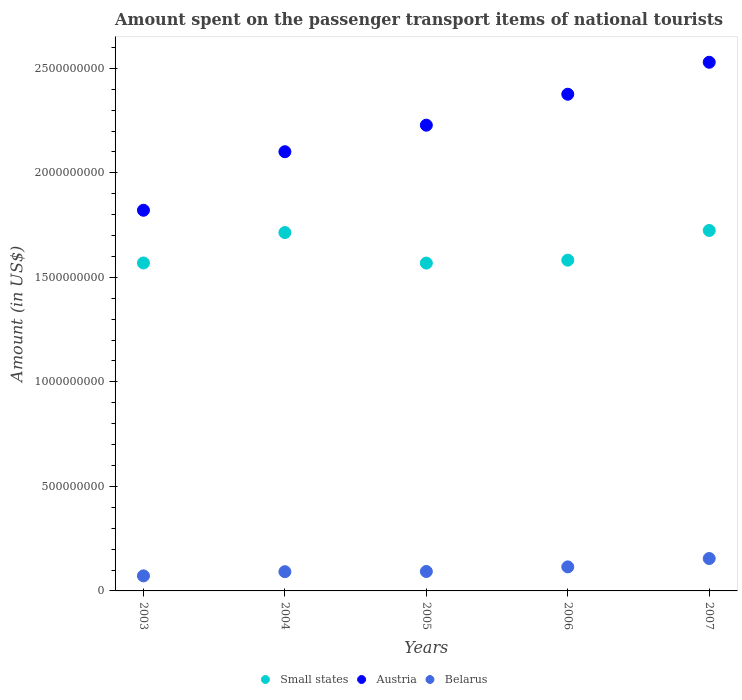What is the amount spent on the passenger transport items of national tourists in Belarus in 2007?
Offer a terse response. 1.55e+08. Across all years, what is the maximum amount spent on the passenger transport items of national tourists in Small states?
Offer a terse response. 1.72e+09. Across all years, what is the minimum amount spent on the passenger transport items of national tourists in Belarus?
Your answer should be very brief. 7.20e+07. In which year was the amount spent on the passenger transport items of national tourists in Belarus maximum?
Give a very brief answer. 2007. In which year was the amount spent on the passenger transport items of national tourists in Austria minimum?
Your answer should be compact. 2003. What is the total amount spent on the passenger transport items of national tourists in Small states in the graph?
Your answer should be very brief. 8.16e+09. What is the difference between the amount spent on the passenger transport items of national tourists in Austria in 2004 and that in 2006?
Provide a short and direct response. -2.75e+08. What is the difference between the amount spent on the passenger transport items of national tourists in Small states in 2004 and the amount spent on the passenger transport items of national tourists in Austria in 2003?
Make the answer very short. -1.07e+08. What is the average amount spent on the passenger transport items of national tourists in Small states per year?
Provide a short and direct response. 1.63e+09. In the year 2004, what is the difference between the amount spent on the passenger transport items of national tourists in Austria and amount spent on the passenger transport items of national tourists in Belarus?
Make the answer very short. 2.01e+09. In how many years, is the amount spent on the passenger transport items of national tourists in Austria greater than 600000000 US$?
Offer a very short reply. 5. What is the ratio of the amount spent on the passenger transport items of national tourists in Belarus in 2003 to that in 2004?
Your answer should be compact. 0.78. Is the amount spent on the passenger transport items of national tourists in Small states in 2005 less than that in 2007?
Provide a succinct answer. Yes. What is the difference between the highest and the second highest amount spent on the passenger transport items of national tourists in Austria?
Keep it short and to the point. 1.53e+08. What is the difference between the highest and the lowest amount spent on the passenger transport items of national tourists in Belarus?
Offer a terse response. 8.30e+07. Is the sum of the amount spent on the passenger transport items of national tourists in Austria in 2005 and 2007 greater than the maximum amount spent on the passenger transport items of national tourists in Belarus across all years?
Your answer should be compact. Yes. Is it the case that in every year, the sum of the amount spent on the passenger transport items of national tourists in Small states and amount spent on the passenger transport items of national tourists in Belarus  is greater than the amount spent on the passenger transport items of national tourists in Austria?
Offer a terse response. No. Is the amount spent on the passenger transport items of national tourists in Belarus strictly greater than the amount spent on the passenger transport items of national tourists in Austria over the years?
Your answer should be very brief. No. How many years are there in the graph?
Provide a succinct answer. 5. What is the difference between two consecutive major ticks on the Y-axis?
Keep it short and to the point. 5.00e+08. Are the values on the major ticks of Y-axis written in scientific E-notation?
Provide a succinct answer. No. Where does the legend appear in the graph?
Offer a very short reply. Bottom center. How are the legend labels stacked?
Keep it short and to the point. Horizontal. What is the title of the graph?
Give a very brief answer. Amount spent on the passenger transport items of national tourists. What is the label or title of the X-axis?
Make the answer very short. Years. What is the label or title of the Y-axis?
Ensure brevity in your answer.  Amount (in US$). What is the Amount (in US$) of Small states in 2003?
Give a very brief answer. 1.57e+09. What is the Amount (in US$) in Austria in 2003?
Your answer should be very brief. 1.82e+09. What is the Amount (in US$) of Belarus in 2003?
Offer a terse response. 7.20e+07. What is the Amount (in US$) of Small states in 2004?
Give a very brief answer. 1.71e+09. What is the Amount (in US$) in Austria in 2004?
Provide a short and direct response. 2.10e+09. What is the Amount (in US$) in Belarus in 2004?
Give a very brief answer. 9.20e+07. What is the Amount (in US$) of Small states in 2005?
Provide a succinct answer. 1.57e+09. What is the Amount (in US$) in Austria in 2005?
Make the answer very short. 2.23e+09. What is the Amount (in US$) of Belarus in 2005?
Your response must be concise. 9.30e+07. What is the Amount (in US$) of Small states in 2006?
Make the answer very short. 1.58e+09. What is the Amount (in US$) in Austria in 2006?
Your response must be concise. 2.38e+09. What is the Amount (in US$) of Belarus in 2006?
Offer a very short reply. 1.15e+08. What is the Amount (in US$) of Small states in 2007?
Provide a succinct answer. 1.72e+09. What is the Amount (in US$) of Austria in 2007?
Make the answer very short. 2.53e+09. What is the Amount (in US$) of Belarus in 2007?
Make the answer very short. 1.55e+08. Across all years, what is the maximum Amount (in US$) of Small states?
Give a very brief answer. 1.72e+09. Across all years, what is the maximum Amount (in US$) in Austria?
Your answer should be compact. 2.53e+09. Across all years, what is the maximum Amount (in US$) of Belarus?
Your response must be concise. 1.55e+08. Across all years, what is the minimum Amount (in US$) of Small states?
Provide a short and direct response. 1.57e+09. Across all years, what is the minimum Amount (in US$) of Austria?
Offer a very short reply. 1.82e+09. Across all years, what is the minimum Amount (in US$) of Belarus?
Make the answer very short. 7.20e+07. What is the total Amount (in US$) of Small states in the graph?
Offer a very short reply. 8.16e+09. What is the total Amount (in US$) of Austria in the graph?
Ensure brevity in your answer.  1.11e+1. What is the total Amount (in US$) in Belarus in the graph?
Ensure brevity in your answer.  5.27e+08. What is the difference between the Amount (in US$) of Small states in 2003 and that in 2004?
Offer a very short reply. -1.45e+08. What is the difference between the Amount (in US$) of Austria in 2003 and that in 2004?
Your answer should be compact. -2.80e+08. What is the difference between the Amount (in US$) of Belarus in 2003 and that in 2004?
Give a very brief answer. -2.00e+07. What is the difference between the Amount (in US$) of Small states in 2003 and that in 2005?
Provide a short and direct response. 5.74e+05. What is the difference between the Amount (in US$) of Austria in 2003 and that in 2005?
Your response must be concise. -4.07e+08. What is the difference between the Amount (in US$) of Belarus in 2003 and that in 2005?
Your response must be concise. -2.10e+07. What is the difference between the Amount (in US$) of Small states in 2003 and that in 2006?
Keep it short and to the point. -1.35e+07. What is the difference between the Amount (in US$) in Austria in 2003 and that in 2006?
Your answer should be compact. -5.55e+08. What is the difference between the Amount (in US$) of Belarus in 2003 and that in 2006?
Offer a very short reply. -4.30e+07. What is the difference between the Amount (in US$) in Small states in 2003 and that in 2007?
Keep it short and to the point. -1.55e+08. What is the difference between the Amount (in US$) of Austria in 2003 and that in 2007?
Make the answer very short. -7.08e+08. What is the difference between the Amount (in US$) of Belarus in 2003 and that in 2007?
Offer a very short reply. -8.30e+07. What is the difference between the Amount (in US$) of Small states in 2004 and that in 2005?
Give a very brief answer. 1.46e+08. What is the difference between the Amount (in US$) in Austria in 2004 and that in 2005?
Your answer should be compact. -1.27e+08. What is the difference between the Amount (in US$) in Small states in 2004 and that in 2006?
Offer a terse response. 1.32e+08. What is the difference between the Amount (in US$) of Austria in 2004 and that in 2006?
Give a very brief answer. -2.75e+08. What is the difference between the Amount (in US$) of Belarus in 2004 and that in 2006?
Offer a terse response. -2.30e+07. What is the difference between the Amount (in US$) of Small states in 2004 and that in 2007?
Make the answer very short. -9.98e+06. What is the difference between the Amount (in US$) in Austria in 2004 and that in 2007?
Keep it short and to the point. -4.28e+08. What is the difference between the Amount (in US$) of Belarus in 2004 and that in 2007?
Offer a very short reply. -6.30e+07. What is the difference between the Amount (in US$) in Small states in 2005 and that in 2006?
Provide a short and direct response. -1.40e+07. What is the difference between the Amount (in US$) in Austria in 2005 and that in 2006?
Make the answer very short. -1.48e+08. What is the difference between the Amount (in US$) of Belarus in 2005 and that in 2006?
Your answer should be very brief. -2.20e+07. What is the difference between the Amount (in US$) of Small states in 2005 and that in 2007?
Provide a succinct answer. -1.56e+08. What is the difference between the Amount (in US$) of Austria in 2005 and that in 2007?
Offer a terse response. -3.01e+08. What is the difference between the Amount (in US$) in Belarus in 2005 and that in 2007?
Make the answer very short. -6.20e+07. What is the difference between the Amount (in US$) of Small states in 2006 and that in 2007?
Offer a very short reply. -1.42e+08. What is the difference between the Amount (in US$) in Austria in 2006 and that in 2007?
Ensure brevity in your answer.  -1.53e+08. What is the difference between the Amount (in US$) in Belarus in 2006 and that in 2007?
Make the answer very short. -4.00e+07. What is the difference between the Amount (in US$) of Small states in 2003 and the Amount (in US$) of Austria in 2004?
Make the answer very short. -5.32e+08. What is the difference between the Amount (in US$) of Small states in 2003 and the Amount (in US$) of Belarus in 2004?
Ensure brevity in your answer.  1.48e+09. What is the difference between the Amount (in US$) in Austria in 2003 and the Amount (in US$) in Belarus in 2004?
Make the answer very short. 1.73e+09. What is the difference between the Amount (in US$) of Small states in 2003 and the Amount (in US$) of Austria in 2005?
Your answer should be compact. -6.59e+08. What is the difference between the Amount (in US$) of Small states in 2003 and the Amount (in US$) of Belarus in 2005?
Your response must be concise. 1.48e+09. What is the difference between the Amount (in US$) in Austria in 2003 and the Amount (in US$) in Belarus in 2005?
Give a very brief answer. 1.73e+09. What is the difference between the Amount (in US$) of Small states in 2003 and the Amount (in US$) of Austria in 2006?
Give a very brief answer. -8.07e+08. What is the difference between the Amount (in US$) in Small states in 2003 and the Amount (in US$) in Belarus in 2006?
Your answer should be compact. 1.45e+09. What is the difference between the Amount (in US$) in Austria in 2003 and the Amount (in US$) in Belarus in 2006?
Offer a very short reply. 1.71e+09. What is the difference between the Amount (in US$) in Small states in 2003 and the Amount (in US$) in Austria in 2007?
Offer a terse response. -9.60e+08. What is the difference between the Amount (in US$) of Small states in 2003 and the Amount (in US$) of Belarus in 2007?
Make the answer very short. 1.41e+09. What is the difference between the Amount (in US$) in Austria in 2003 and the Amount (in US$) in Belarus in 2007?
Provide a short and direct response. 1.67e+09. What is the difference between the Amount (in US$) in Small states in 2004 and the Amount (in US$) in Austria in 2005?
Your response must be concise. -5.14e+08. What is the difference between the Amount (in US$) of Small states in 2004 and the Amount (in US$) of Belarus in 2005?
Ensure brevity in your answer.  1.62e+09. What is the difference between the Amount (in US$) of Austria in 2004 and the Amount (in US$) of Belarus in 2005?
Offer a very short reply. 2.01e+09. What is the difference between the Amount (in US$) of Small states in 2004 and the Amount (in US$) of Austria in 2006?
Offer a very short reply. -6.62e+08. What is the difference between the Amount (in US$) in Small states in 2004 and the Amount (in US$) in Belarus in 2006?
Offer a very short reply. 1.60e+09. What is the difference between the Amount (in US$) in Austria in 2004 and the Amount (in US$) in Belarus in 2006?
Keep it short and to the point. 1.99e+09. What is the difference between the Amount (in US$) of Small states in 2004 and the Amount (in US$) of Austria in 2007?
Provide a succinct answer. -8.15e+08. What is the difference between the Amount (in US$) of Small states in 2004 and the Amount (in US$) of Belarus in 2007?
Ensure brevity in your answer.  1.56e+09. What is the difference between the Amount (in US$) in Austria in 2004 and the Amount (in US$) in Belarus in 2007?
Give a very brief answer. 1.95e+09. What is the difference between the Amount (in US$) in Small states in 2005 and the Amount (in US$) in Austria in 2006?
Your answer should be very brief. -8.08e+08. What is the difference between the Amount (in US$) in Small states in 2005 and the Amount (in US$) in Belarus in 2006?
Give a very brief answer. 1.45e+09. What is the difference between the Amount (in US$) of Austria in 2005 and the Amount (in US$) of Belarus in 2006?
Provide a short and direct response. 2.11e+09. What is the difference between the Amount (in US$) of Small states in 2005 and the Amount (in US$) of Austria in 2007?
Your answer should be very brief. -9.61e+08. What is the difference between the Amount (in US$) of Small states in 2005 and the Amount (in US$) of Belarus in 2007?
Provide a short and direct response. 1.41e+09. What is the difference between the Amount (in US$) of Austria in 2005 and the Amount (in US$) of Belarus in 2007?
Give a very brief answer. 2.07e+09. What is the difference between the Amount (in US$) in Small states in 2006 and the Amount (in US$) in Austria in 2007?
Keep it short and to the point. -9.47e+08. What is the difference between the Amount (in US$) in Small states in 2006 and the Amount (in US$) in Belarus in 2007?
Offer a very short reply. 1.43e+09. What is the difference between the Amount (in US$) in Austria in 2006 and the Amount (in US$) in Belarus in 2007?
Provide a succinct answer. 2.22e+09. What is the average Amount (in US$) in Small states per year?
Provide a short and direct response. 1.63e+09. What is the average Amount (in US$) in Austria per year?
Your answer should be very brief. 2.21e+09. What is the average Amount (in US$) in Belarus per year?
Make the answer very short. 1.05e+08. In the year 2003, what is the difference between the Amount (in US$) of Small states and Amount (in US$) of Austria?
Keep it short and to the point. -2.52e+08. In the year 2003, what is the difference between the Amount (in US$) of Small states and Amount (in US$) of Belarus?
Provide a short and direct response. 1.50e+09. In the year 2003, what is the difference between the Amount (in US$) in Austria and Amount (in US$) in Belarus?
Offer a terse response. 1.75e+09. In the year 2004, what is the difference between the Amount (in US$) of Small states and Amount (in US$) of Austria?
Your answer should be compact. -3.87e+08. In the year 2004, what is the difference between the Amount (in US$) in Small states and Amount (in US$) in Belarus?
Your answer should be compact. 1.62e+09. In the year 2004, what is the difference between the Amount (in US$) in Austria and Amount (in US$) in Belarus?
Offer a very short reply. 2.01e+09. In the year 2005, what is the difference between the Amount (in US$) in Small states and Amount (in US$) in Austria?
Give a very brief answer. -6.60e+08. In the year 2005, what is the difference between the Amount (in US$) in Small states and Amount (in US$) in Belarus?
Make the answer very short. 1.48e+09. In the year 2005, what is the difference between the Amount (in US$) of Austria and Amount (in US$) of Belarus?
Provide a succinct answer. 2.14e+09. In the year 2006, what is the difference between the Amount (in US$) of Small states and Amount (in US$) of Austria?
Keep it short and to the point. -7.94e+08. In the year 2006, what is the difference between the Amount (in US$) in Small states and Amount (in US$) in Belarus?
Offer a very short reply. 1.47e+09. In the year 2006, what is the difference between the Amount (in US$) of Austria and Amount (in US$) of Belarus?
Give a very brief answer. 2.26e+09. In the year 2007, what is the difference between the Amount (in US$) in Small states and Amount (in US$) in Austria?
Give a very brief answer. -8.05e+08. In the year 2007, what is the difference between the Amount (in US$) of Small states and Amount (in US$) of Belarus?
Your answer should be compact. 1.57e+09. In the year 2007, what is the difference between the Amount (in US$) of Austria and Amount (in US$) of Belarus?
Provide a short and direct response. 2.37e+09. What is the ratio of the Amount (in US$) of Small states in 2003 to that in 2004?
Your answer should be very brief. 0.92. What is the ratio of the Amount (in US$) of Austria in 2003 to that in 2004?
Keep it short and to the point. 0.87. What is the ratio of the Amount (in US$) in Belarus in 2003 to that in 2004?
Offer a very short reply. 0.78. What is the ratio of the Amount (in US$) in Small states in 2003 to that in 2005?
Offer a terse response. 1. What is the ratio of the Amount (in US$) in Austria in 2003 to that in 2005?
Ensure brevity in your answer.  0.82. What is the ratio of the Amount (in US$) in Belarus in 2003 to that in 2005?
Your answer should be compact. 0.77. What is the ratio of the Amount (in US$) in Austria in 2003 to that in 2006?
Your response must be concise. 0.77. What is the ratio of the Amount (in US$) in Belarus in 2003 to that in 2006?
Provide a short and direct response. 0.63. What is the ratio of the Amount (in US$) of Small states in 2003 to that in 2007?
Give a very brief answer. 0.91. What is the ratio of the Amount (in US$) of Austria in 2003 to that in 2007?
Offer a terse response. 0.72. What is the ratio of the Amount (in US$) of Belarus in 2003 to that in 2007?
Give a very brief answer. 0.46. What is the ratio of the Amount (in US$) of Small states in 2004 to that in 2005?
Provide a short and direct response. 1.09. What is the ratio of the Amount (in US$) of Austria in 2004 to that in 2005?
Offer a terse response. 0.94. What is the ratio of the Amount (in US$) of Small states in 2004 to that in 2006?
Offer a very short reply. 1.08. What is the ratio of the Amount (in US$) in Austria in 2004 to that in 2006?
Offer a very short reply. 0.88. What is the ratio of the Amount (in US$) in Small states in 2004 to that in 2007?
Provide a short and direct response. 0.99. What is the ratio of the Amount (in US$) of Austria in 2004 to that in 2007?
Ensure brevity in your answer.  0.83. What is the ratio of the Amount (in US$) in Belarus in 2004 to that in 2007?
Keep it short and to the point. 0.59. What is the ratio of the Amount (in US$) of Small states in 2005 to that in 2006?
Provide a succinct answer. 0.99. What is the ratio of the Amount (in US$) of Austria in 2005 to that in 2006?
Your response must be concise. 0.94. What is the ratio of the Amount (in US$) in Belarus in 2005 to that in 2006?
Offer a very short reply. 0.81. What is the ratio of the Amount (in US$) in Small states in 2005 to that in 2007?
Give a very brief answer. 0.91. What is the ratio of the Amount (in US$) in Austria in 2005 to that in 2007?
Offer a terse response. 0.88. What is the ratio of the Amount (in US$) in Small states in 2006 to that in 2007?
Provide a short and direct response. 0.92. What is the ratio of the Amount (in US$) of Austria in 2006 to that in 2007?
Make the answer very short. 0.94. What is the ratio of the Amount (in US$) of Belarus in 2006 to that in 2007?
Provide a succinct answer. 0.74. What is the difference between the highest and the second highest Amount (in US$) in Small states?
Make the answer very short. 9.98e+06. What is the difference between the highest and the second highest Amount (in US$) of Austria?
Offer a very short reply. 1.53e+08. What is the difference between the highest and the second highest Amount (in US$) of Belarus?
Your answer should be very brief. 4.00e+07. What is the difference between the highest and the lowest Amount (in US$) in Small states?
Keep it short and to the point. 1.56e+08. What is the difference between the highest and the lowest Amount (in US$) of Austria?
Keep it short and to the point. 7.08e+08. What is the difference between the highest and the lowest Amount (in US$) of Belarus?
Make the answer very short. 8.30e+07. 